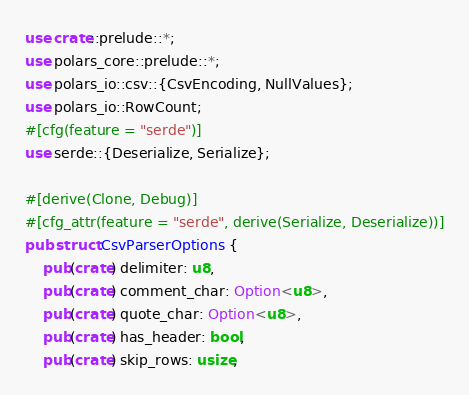<code> <loc_0><loc_0><loc_500><loc_500><_Rust_>use crate::prelude::*;
use polars_core::prelude::*;
use polars_io::csv::{CsvEncoding, NullValues};
use polars_io::RowCount;
#[cfg(feature = "serde")]
use serde::{Deserialize, Serialize};

#[derive(Clone, Debug)]
#[cfg_attr(feature = "serde", derive(Serialize, Deserialize))]
pub struct CsvParserOptions {
    pub(crate) delimiter: u8,
    pub(crate) comment_char: Option<u8>,
    pub(crate) quote_char: Option<u8>,
    pub(crate) has_header: bool,
    pub(crate) skip_rows: usize,</code> 